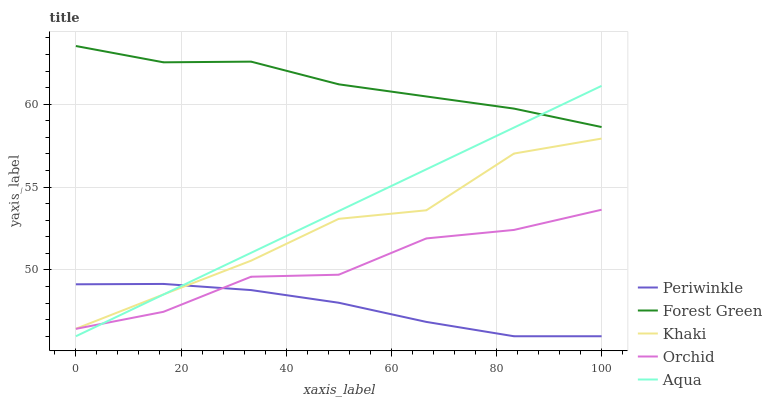Does Periwinkle have the minimum area under the curve?
Answer yes or no. Yes. Does Forest Green have the maximum area under the curve?
Answer yes or no. Yes. Does Khaki have the minimum area under the curve?
Answer yes or no. No. Does Khaki have the maximum area under the curve?
Answer yes or no. No. Is Aqua the smoothest?
Answer yes or no. Yes. Is Khaki the roughest?
Answer yes or no. Yes. Is Forest Green the smoothest?
Answer yes or no. No. Is Forest Green the roughest?
Answer yes or no. No. Does Aqua have the lowest value?
Answer yes or no. Yes. Does Khaki have the lowest value?
Answer yes or no. No. Does Forest Green have the highest value?
Answer yes or no. Yes. Does Khaki have the highest value?
Answer yes or no. No. Is Khaki less than Forest Green?
Answer yes or no. Yes. Is Forest Green greater than Periwinkle?
Answer yes or no. Yes. Does Aqua intersect Orchid?
Answer yes or no. Yes. Is Aqua less than Orchid?
Answer yes or no. No. Is Aqua greater than Orchid?
Answer yes or no. No. Does Khaki intersect Forest Green?
Answer yes or no. No. 